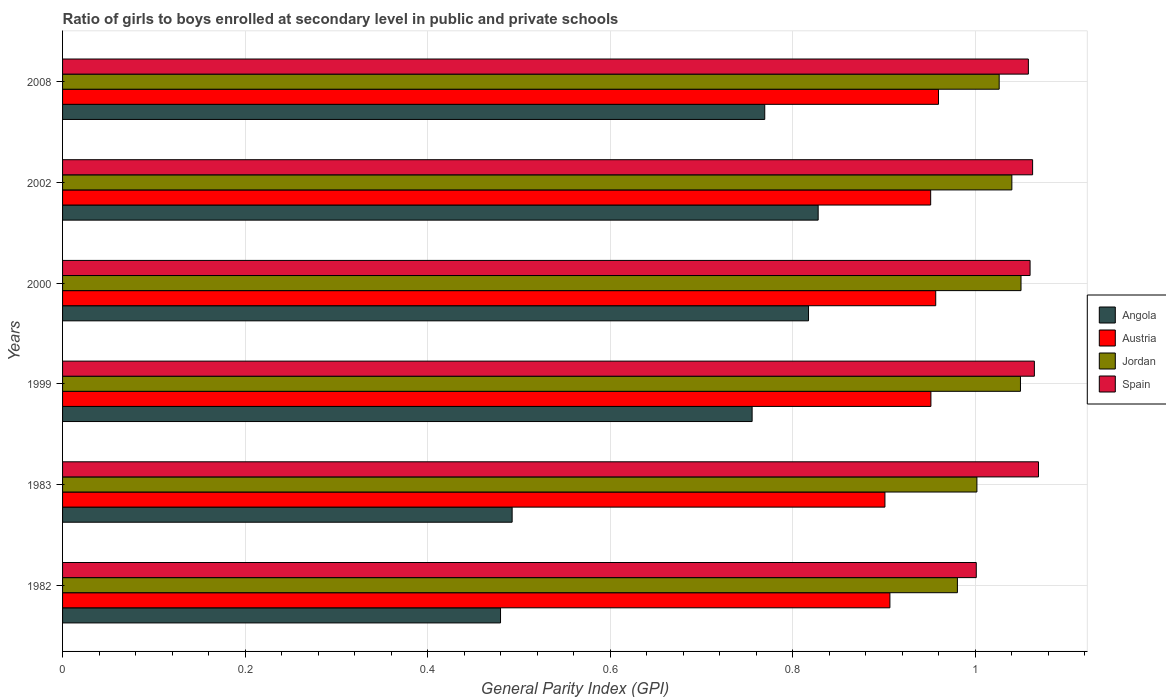How many groups of bars are there?
Give a very brief answer. 6. Are the number of bars per tick equal to the number of legend labels?
Keep it short and to the point. Yes. Are the number of bars on each tick of the Y-axis equal?
Give a very brief answer. Yes. How many bars are there on the 3rd tick from the top?
Provide a succinct answer. 4. How many bars are there on the 5th tick from the bottom?
Provide a short and direct response. 4. What is the label of the 1st group of bars from the top?
Your response must be concise. 2008. What is the general parity index in Angola in 1982?
Give a very brief answer. 0.48. Across all years, what is the maximum general parity index in Angola?
Ensure brevity in your answer.  0.83. Across all years, what is the minimum general parity index in Spain?
Provide a succinct answer. 1. In which year was the general parity index in Austria maximum?
Offer a very short reply. 2008. In which year was the general parity index in Austria minimum?
Your response must be concise. 1983. What is the total general parity index in Jordan in the graph?
Offer a terse response. 6.15. What is the difference between the general parity index in Angola in 1983 and that in 2002?
Ensure brevity in your answer.  -0.34. What is the difference between the general parity index in Jordan in 1983 and the general parity index in Angola in 1999?
Offer a terse response. 0.25. What is the average general parity index in Spain per year?
Your answer should be compact. 1.05. In the year 1999, what is the difference between the general parity index in Austria and general parity index in Angola?
Give a very brief answer. 0.2. What is the ratio of the general parity index in Spain in 1999 to that in 2000?
Provide a short and direct response. 1. Is the difference between the general parity index in Austria in 2000 and 2008 greater than the difference between the general parity index in Angola in 2000 and 2008?
Keep it short and to the point. No. What is the difference between the highest and the second highest general parity index in Jordan?
Provide a succinct answer. 0. What is the difference between the highest and the lowest general parity index in Angola?
Offer a very short reply. 0.35. Is the sum of the general parity index in Austria in 1982 and 2008 greater than the maximum general parity index in Angola across all years?
Provide a succinct answer. Yes. Is it the case that in every year, the sum of the general parity index in Austria and general parity index in Angola is greater than the sum of general parity index in Jordan and general parity index in Spain?
Your response must be concise. No. What does the 3rd bar from the top in 1982 represents?
Offer a terse response. Austria. What does the 3rd bar from the bottom in 2002 represents?
Your answer should be compact. Jordan. How many bars are there?
Ensure brevity in your answer.  24. What is the difference between two consecutive major ticks on the X-axis?
Your answer should be very brief. 0.2. Does the graph contain grids?
Provide a succinct answer. Yes. How many legend labels are there?
Offer a very short reply. 4. How are the legend labels stacked?
Offer a very short reply. Vertical. What is the title of the graph?
Make the answer very short. Ratio of girls to boys enrolled at secondary level in public and private schools. Does "Faeroe Islands" appear as one of the legend labels in the graph?
Keep it short and to the point. No. What is the label or title of the X-axis?
Offer a terse response. General Parity Index (GPI). What is the label or title of the Y-axis?
Ensure brevity in your answer.  Years. What is the General Parity Index (GPI) of Angola in 1982?
Make the answer very short. 0.48. What is the General Parity Index (GPI) of Austria in 1982?
Offer a terse response. 0.91. What is the General Parity Index (GPI) in Jordan in 1982?
Your answer should be very brief. 0.98. What is the General Parity Index (GPI) of Spain in 1982?
Your response must be concise. 1. What is the General Parity Index (GPI) in Angola in 1983?
Offer a very short reply. 0.49. What is the General Parity Index (GPI) of Austria in 1983?
Give a very brief answer. 0.9. What is the General Parity Index (GPI) in Jordan in 1983?
Ensure brevity in your answer.  1. What is the General Parity Index (GPI) in Spain in 1983?
Give a very brief answer. 1.07. What is the General Parity Index (GPI) in Angola in 1999?
Provide a succinct answer. 0.76. What is the General Parity Index (GPI) of Austria in 1999?
Your answer should be very brief. 0.95. What is the General Parity Index (GPI) in Jordan in 1999?
Ensure brevity in your answer.  1.05. What is the General Parity Index (GPI) of Spain in 1999?
Your answer should be very brief. 1.06. What is the General Parity Index (GPI) in Angola in 2000?
Provide a short and direct response. 0.82. What is the General Parity Index (GPI) of Austria in 2000?
Ensure brevity in your answer.  0.96. What is the General Parity Index (GPI) of Jordan in 2000?
Your response must be concise. 1.05. What is the General Parity Index (GPI) in Spain in 2000?
Make the answer very short. 1.06. What is the General Parity Index (GPI) in Angola in 2002?
Offer a terse response. 0.83. What is the General Parity Index (GPI) in Austria in 2002?
Ensure brevity in your answer.  0.95. What is the General Parity Index (GPI) in Jordan in 2002?
Offer a terse response. 1.04. What is the General Parity Index (GPI) of Spain in 2002?
Ensure brevity in your answer.  1.06. What is the General Parity Index (GPI) in Angola in 2008?
Keep it short and to the point. 0.77. What is the General Parity Index (GPI) of Austria in 2008?
Keep it short and to the point. 0.96. What is the General Parity Index (GPI) in Jordan in 2008?
Give a very brief answer. 1.03. What is the General Parity Index (GPI) in Spain in 2008?
Your answer should be compact. 1.06. Across all years, what is the maximum General Parity Index (GPI) in Angola?
Offer a very short reply. 0.83. Across all years, what is the maximum General Parity Index (GPI) in Austria?
Keep it short and to the point. 0.96. Across all years, what is the maximum General Parity Index (GPI) in Jordan?
Offer a very short reply. 1.05. Across all years, what is the maximum General Parity Index (GPI) in Spain?
Give a very brief answer. 1.07. Across all years, what is the minimum General Parity Index (GPI) of Angola?
Make the answer very short. 0.48. Across all years, what is the minimum General Parity Index (GPI) in Austria?
Your answer should be very brief. 0.9. Across all years, what is the minimum General Parity Index (GPI) in Jordan?
Offer a terse response. 0.98. Across all years, what is the minimum General Parity Index (GPI) of Spain?
Offer a very short reply. 1. What is the total General Parity Index (GPI) of Angola in the graph?
Keep it short and to the point. 4.14. What is the total General Parity Index (GPI) of Austria in the graph?
Give a very brief answer. 5.63. What is the total General Parity Index (GPI) of Jordan in the graph?
Provide a short and direct response. 6.15. What is the total General Parity Index (GPI) of Spain in the graph?
Offer a very short reply. 6.32. What is the difference between the General Parity Index (GPI) of Angola in 1982 and that in 1983?
Provide a succinct answer. -0.01. What is the difference between the General Parity Index (GPI) in Austria in 1982 and that in 1983?
Make the answer very short. 0.01. What is the difference between the General Parity Index (GPI) in Jordan in 1982 and that in 1983?
Offer a very short reply. -0.02. What is the difference between the General Parity Index (GPI) in Spain in 1982 and that in 1983?
Offer a very short reply. -0.07. What is the difference between the General Parity Index (GPI) of Angola in 1982 and that in 1999?
Provide a succinct answer. -0.28. What is the difference between the General Parity Index (GPI) in Austria in 1982 and that in 1999?
Your answer should be compact. -0.04. What is the difference between the General Parity Index (GPI) in Jordan in 1982 and that in 1999?
Ensure brevity in your answer.  -0.07. What is the difference between the General Parity Index (GPI) of Spain in 1982 and that in 1999?
Provide a succinct answer. -0.06. What is the difference between the General Parity Index (GPI) of Angola in 1982 and that in 2000?
Give a very brief answer. -0.34. What is the difference between the General Parity Index (GPI) of Austria in 1982 and that in 2000?
Ensure brevity in your answer.  -0.05. What is the difference between the General Parity Index (GPI) in Jordan in 1982 and that in 2000?
Your answer should be compact. -0.07. What is the difference between the General Parity Index (GPI) in Spain in 1982 and that in 2000?
Offer a very short reply. -0.06. What is the difference between the General Parity Index (GPI) in Angola in 1982 and that in 2002?
Give a very brief answer. -0.35. What is the difference between the General Parity Index (GPI) in Austria in 1982 and that in 2002?
Offer a very short reply. -0.04. What is the difference between the General Parity Index (GPI) of Jordan in 1982 and that in 2002?
Offer a very short reply. -0.06. What is the difference between the General Parity Index (GPI) of Spain in 1982 and that in 2002?
Offer a terse response. -0.06. What is the difference between the General Parity Index (GPI) of Angola in 1982 and that in 2008?
Provide a succinct answer. -0.29. What is the difference between the General Parity Index (GPI) in Austria in 1982 and that in 2008?
Offer a very short reply. -0.05. What is the difference between the General Parity Index (GPI) in Jordan in 1982 and that in 2008?
Your response must be concise. -0.05. What is the difference between the General Parity Index (GPI) in Spain in 1982 and that in 2008?
Offer a very short reply. -0.06. What is the difference between the General Parity Index (GPI) in Angola in 1983 and that in 1999?
Your response must be concise. -0.26. What is the difference between the General Parity Index (GPI) in Austria in 1983 and that in 1999?
Your response must be concise. -0.05. What is the difference between the General Parity Index (GPI) of Jordan in 1983 and that in 1999?
Offer a very short reply. -0.05. What is the difference between the General Parity Index (GPI) of Spain in 1983 and that in 1999?
Make the answer very short. 0. What is the difference between the General Parity Index (GPI) in Angola in 1983 and that in 2000?
Offer a terse response. -0.32. What is the difference between the General Parity Index (GPI) in Austria in 1983 and that in 2000?
Offer a very short reply. -0.06. What is the difference between the General Parity Index (GPI) in Jordan in 1983 and that in 2000?
Give a very brief answer. -0.05. What is the difference between the General Parity Index (GPI) of Spain in 1983 and that in 2000?
Offer a terse response. 0.01. What is the difference between the General Parity Index (GPI) of Angola in 1983 and that in 2002?
Offer a very short reply. -0.34. What is the difference between the General Parity Index (GPI) of Austria in 1983 and that in 2002?
Keep it short and to the point. -0.05. What is the difference between the General Parity Index (GPI) in Jordan in 1983 and that in 2002?
Provide a short and direct response. -0.04. What is the difference between the General Parity Index (GPI) in Spain in 1983 and that in 2002?
Give a very brief answer. 0.01. What is the difference between the General Parity Index (GPI) in Angola in 1983 and that in 2008?
Keep it short and to the point. -0.28. What is the difference between the General Parity Index (GPI) of Austria in 1983 and that in 2008?
Offer a very short reply. -0.06. What is the difference between the General Parity Index (GPI) in Jordan in 1983 and that in 2008?
Ensure brevity in your answer.  -0.02. What is the difference between the General Parity Index (GPI) in Spain in 1983 and that in 2008?
Offer a very short reply. 0.01. What is the difference between the General Parity Index (GPI) in Angola in 1999 and that in 2000?
Make the answer very short. -0.06. What is the difference between the General Parity Index (GPI) of Austria in 1999 and that in 2000?
Offer a terse response. -0.01. What is the difference between the General Parity Index (GPI) of Jordan in 1999 and that in 2000?
Provide a short and direct response. -0. What is the difference between the General Parity Index (GPI) of Spain in 1999 and that in 2000?
Give a very brief answer. 0. What is the difference between the General Parity Index (GPI) in Angola in 1999 and that in 2002?
Provide a short and direct response. -0.07. What is the difference between the General Parity Index (GPI) of Jordan in 1999 and that in 2002?
Provide a succinct answer. 0.01. What is the difference between the General Parity Index (GPI) of Spain in 1999 and that in 2002?
Your response must be concise. 0. What is the difference between the General Parity Index (GPI) in Angola in 1999 and that in 2008?
Offer a terse response. -0.01. What is the difference between the General Parity Index (GPI) of Austria in 1999 and that in 2008?
Your response must be concise. -0.01. What is the difference between the General Parity Index (GPI) of Jordan in 1999 and that in 2008?
Offer a very short reply. 0.02. What is the difference between the General Parity Index (GPI) in Spain in 1999 and that in 2008?
Your answer should be compact. 0.01. What is the difference between the General Parity Index (GPI) of Angola in 2000 and that in 2002?
Make the answer very short. -0.01. What is the difference between the General Parity Index (GPI) in Austria in 2000 and that in 2002?
Provide a short and direct response. 0.01. What is the difference between the General Parity Index (GPI) in Jordan in 2000 and that in 2002?
Provide a short and direct response. 0.01. What is the difference between the General Parity Index (GPI) of Spain in 2000 and that in 2002?
Give a very brief answer. -0. What is the difference between the General Parity Index (GPI) in Angola in 2000 and that in 2008?
Keep it short and to the point. 0.05. What is the difference between the General Parity Index (GPI) of Austria in 2000 and that in 2008?
Offer a very short reply. -0. What is the difference between the General Parity Index (GPI) of Jordan in 2000 and that in 2008?
Offer a terse response. 0.02. What is the difference between the General Parity Index (GPI) in Spain in 2000 and that in 2008?
Make the answer very short. 0. What is the difference between the General Parity Index (GPI) of Angola in 2002 and that in 2008?
Ensure brevity in your answer.  0.06. What is the difference between the General Parity Index (GPI) of Austria in 2002 and that in 2008?
Ensure brevity in your answer.  -0.01. What is the difference between the General Parity Index (GPI) of Jordan in 2002 and that in 2008?
Your response must be concise. 0.01. What is the difference between the General Parity Index (GPI) of Spain in 2002 and that in 2008?
Provide a succinct answer. 0. What is the difference between the General Parity Index (GPI) in Angola in 1982 and the General Parity Index (GPI) in Austria in 1983?
Keep it short and to the point. -0.42. What is the difference between the General Parity Index (GPI) in Angola in 1982 and the General Parity Index (GPI) in Jordan in 1983?
Provide a short and direct response. -0.52. What is the difference between the General Parity Index (GPI) of Angola in 1982 and the General Parity Index (GPI) of Spain in 1983?
Your answer should be very brief. -0.59. What is the difference between the General Parity Index (GPI) of Austria in 1982 and the General Parity Index (GPI) of Jordan in 1983?
Make the answer very short. -0.1. What is the difference between the General Parity Index (GPI) in Austria in 1982 and the General Parity Index (GPI) in Spain in 1983?
Provide a short and direct response. -0.16. What is the difference between the General Parity Index (GPI) in Jordan in 1982 and the General Parity Index (GPI) in Spain in 1983?
Your answer should be compact. -0.09. What is the difference between the General Parity Index (GPI) in Angola in 1982 and the General Parity Index (GPI) in Austria in 1999?
Provide a succinct answer. -0.47. What is the difference between the General Parity Index (GPI) in Angola in 1982 and the General Parity Index (GPI) in Jordan in 1999?
Offer a very short reply. -0.57. What is the difference between the General Parity Index (GPI) of Angola in 1982 and the General Parity Index (GPI) of Spain in 1999?
Your answer should be compact. -0.58. What is the difference between the General Parity Index (GPI) of Austria in 1982 and the General Parity Index (GPI) of Jordan in 1999?
Offer a terse response. -0.14. What is the difference between the General Parity Index (GPI) of Austria in 1982 and the General Parity Index (GPI) of Spain in 1999?
Provide a succinct answer. -0.16. What is the difference between the General Parity Index (GPI) of Jordan in 1982 and the General Parity Index (GPI) of Spain in 1999?
Make the answer very short. -0.08. What is the difference between the General Parity Index (GPI) of Angola in 1982 and the General Parity Index (GPI) of Austria in 2000?
Ensure brevity in your answer.  -0.48. What is the difference between the General Parity Index (GPI) in Angola in 1982 and the General Parity Index (GPI) in Jordan in 2000?
Your answer should be very brief. -0.57. What is the difference between the General Parity Index (GPI) in Angola in 1982 and the General Parity Index (GPI) in Spain in 2000?
Ensure brevity in your answer.  -0.58. What is the difference between the General Parity Index (GPI) in Austria in 1982 and the General Parity Index (GPI) in Jordan in 2000?
Ensure brevity in your answer.  -0.14. What is the difference between the General Parity Index (GPI) of Austria in 1982 and the General Parity Index (GPI) of Spain in 2000?
Offer a terse response. -0.15. What is the difference between the General Parity Index (GPI) in Jordan in 1982 and the General Parity Index (GPI) in Spain in 2000?
Provide a short and direct response. -0.08. What is the difference between the General Parity Index (GPI) of Angola in 1982 and the General Parity Index (GPI) of Austria in 2002?
Make the answer very short. -0.47. What is the difference between the General Parity Index (GPI) of Angola in 1982 and the General Parity Index (GPI) of Jordan in 2002?
Provide a short and direct response. -0.56. What is the difference between the General Parity Index (GPI) of Angola in 1982 and the General Parity Index (GPI) of Spain in 2002?
Offer a terse response. -0.58. What is the difference between the General Parity Index (GPI) of Austria in 1982 and the General Parity Index (GPI) of Jordan in 2002?
Keep it short and to the point. -0.13. What is the difference between the General Parity Index (GPI) in Austria in 1982 and the General Parity Index (GPI) in Spain in 2002?
Your answer should be very brief. -0.16. What is the difference between the General Parity Index (GPI) in Jordan in 1982 and the General Parity Index (GPI) in Spain in 2002?
Make the answer very short. -0.08. What is the difference between the General Parity Index (GPI) in Angola in 1982 and the General Parity Index (GPI) in Austria in 2008?
Keep it short and to the point. -0.48. What is the difference between the General Parity Index (GPI) in Angola in 1982 and the General Parity Index (GPI) in Jordan in 2008?
Offer a very short reply. -0.55. What is the difference between the General Parity Index (GPI) in Angola in 1982 and the General Parity Index (GPI) in Spain in 2008?
Provide a short and direct response. -0.58. What is the difference between the General Parity Index (GPI) of Austria in 1982 and the General Parity Index (GPI) of Jordan in 2008?
Your answer should be very brief. -0.12. What is the difference between the General Parity Index (GPI) in Austria in 1982 and the General Parity Index (GPI) in Spain in 2008?
Give a very brief answer. -0.15. What is the difference between the General Parity Index (GPI) of Jordan in 1982 and the General Parity Index (GPI) of Spain in 2008?
Your response must be concise. -0.08. What is the difference between the General Parity Index (GPI) in Angola in 1983 and the General Parity Index (GPI) in Austria in 1999?
Keep it short and to the point. -0.46. What is the difference between the General Parity Index (GPI) in Angola in 1983 and the General Parity Index (GPI) in Jordan in 1999?
Keep it short and to the point. -0.56. What is the difference between the General Parity Index (GPI) of Angola in 1983 and the General Parity Index (GPI) of Spain in 1999?
Offer a very short reply. -0.57. What is the difference between the General Parity Index (GPI) of Austria in 1983 and the General Parity Index (GPI) of Jordan in 1999?
Provide a succinct answer. -0.15. What is the difference between the General Parity Index (GPI) in Austria in 1983 and the General Parity Index (GPI) in Spain in 1999?
Your answer should be compact. -0.16. What is the difference between the General Parity Index (GPI) in Jordan in 1983 and the General Parity Index (GPI) in Spain in 1999?
Keep it short and to the point. -0.06. What is the difference between the General Parity Index (GPI) in Angola in 1983 and the General Parity Index (GPI) in Austria in 2000?
Keep it short and to the point. -0.46. What is the difference between the General Parity Index (GPI) in Angola in 1983 and the General Parity Index (GPI) in Jordan in 2000?
Ensure brevity in your answer.  -0.56. What is the difference between the General Parity Index (GPI) of Angola in 1983 and the General Parity Index (GPI) of Spain in 2000?
Your answer should be very brief. -0.57. What is the difference between the General Parity Index (GPI) of Austria in 1983 and the General Parity Index (GPI) of Jordan in 2000?
Provide a succinct answer. -0.15. What is the difference between the General Parity Index (GPI) in Austria in 1983 and the General Parity Index (GPI) in Spain in 2000?
Provide a succinct answer. -0.16. What is the difference between the General Parity Index (GPI) in Jordan in 1983 and the General Parity Index (GPI) in Spain in 2000?
Your answer should be compact. -0.06. What is the difference between the General Parity Index (GPI) in Angola in 1983 and the General Parity Index (GPI) in Austria in 2002?
Keep it short and to the point. -0.46. What is the difference between the General Parity Index (GPI) of Angola in 1983 and the General Parity Index (GPI) of Jordan in 2002?
Offer a terse response. -0.55. What is the difference between the General Parity Index (GPI) in Angola in 1983 and the General Parity Index (GPI) in Spain in 2002?
Your answer should be very brief. -0.57. What is the difference between the General Parity Index (GPI) in Austria in 1983 and the General Parity Index (GPI) in Jordan in 2002?
Give a very brief answer. -0.14. What is the difference between the General Parity Index (GPI) in Austria in 1983 and the General Parity Index (GPI) in Spain in 2002?
Offer a terse response. -0.16. What is the difference between the General Parity Index (GPI) in Jordan in 1983 and the General Parity Index (GPI) in Spain in 2002?
Give a very brief answer. -0.06. What is the difference between the General Parity Index (GPI) in Angola in 1983 and the General Parity Index (GPI) in Austria in 2008?
Keep it short and to the point. -0.47. What is the difference between the General Parity Index (GPI) of Angola in 1983 and the General Parity Index (GPI) of Jordan in 2008?
Your answer should be very brief. -0.53. What is the difference between the General Parity Index (GPI) in Angola in 1983 and the General Parity Index (GPI) in Spain in 2008?
Keep it short and to the point. -0.57. What is the difference between the General Parity Index (GPI) of Austria in 1983 and the General Parity Index (GPI) of Jordan in 2008?
Your response must be concise. -0.13. What is the difference between the General Parity Index (GPI) in Austria in 1983 and the General Parity Index (GPI) in Spain in 2008?
Offer a very short reply. -0.16. What is the difference between the General Parity Index (GPI) in Jordan in 1983 and the General Parity Index (GPI) in Spain in 2008?
Offer a very short reply. -0.06. What is the difference between the General Parity Index (GPI) in Angola in 1999 and the General Parity Index (GPI) in Austria in 2000?
Your response must be concise. -0.2. What is the difference between the General Parity Index (GPI) in Angola in 1999 and the General Parity Index (GPI) in Jordan in 2000?
Offer a terse response. -0.29. What is the difference between the General Parity Index (GPI) of Angola in 1999 and the General Parity Index (GPI) of Spain in 2000?
Provide a succinct answer. -0.3. What is the difference between the General Parity Index (GPI) of Austria in 1999 and the General Parity Index (GPI) of Jordan in 2000?
Provide a succinct answer. -0.1. What is the difference between the General Parity Index (GPI) of Austria in 1999 and the General Parity Index (GPI) of Spain in 2000?
Provide a succinct answer. -0.11. What is the difference between the General Parity Index (GPI) in Jordan in 1999 and the General Parity Index (GPI) in Spain in 2000?
Your response must be concise. -0.01. What is the difference between the General Parity Index (GPI) in Angola in 1999 and the General Parity Index (GPI) in Austria in 2002?
Your answer should be compact. -0.2. What is the difference between the General Parity Index (GPI) in Angola in 1999 and the General Parity Index (GPI) in Jordan in 2002?
Your response must be concise. -0.28. What is the difference between the General Parity Index (GPI) in Angola in 1999 and the General Parity Index (GPI) in Spain in 2002?
Your answer should be compact. -0.31. What is the difference between the General Parity Index (GPI) of Austria in 1999 and the General Parity Index (GPI) of Jordan in 2002?
Your answer should be compact. -0.09. What is the difference between the General Parity Index (GPI) of Austria in 1999 and the General Parity Index (GPI) of Spain in 2002?
Provide a succinct answer. -0.11. What is the difference between the General Parity Index (GPI) in Jordan in 1999 and the General Parity Index (GPI) in Spain in 2002?
Your answer should be compact. -0.01. What is the difference between the General Parity Index (GPI) in Angola in 1999 and the General Parity Index (GPI) in Austria in 2008?
Give a very brief answer. -0.2. What is the difference between the General Parity Index (GPI) in Angola in 1999 and the General Parity Index (GPI) in Jordan in 2008?
Your response must be concise. -0.27. What is the difference between the General Parity Index (GPI) in Angola in 1999 and the General Parity Index (GPI) in Spain in 2008?
Offer a very short reply. -0.3. What is the difference between the General Parity Index (GPI) in Austria in 1999 and the General Parity Index (GPI) in Jordan in 2008?
Your answer should be very brief. -0.07. What is the difference between the General Parity Index (GPI) of Austria in 1999 and the General Parity Index (GPI) of Spain in 2008?
Keep it short and to the point. -0.11. What is the difference between the General Parity Index (GPI) of Jordan in 1999 and the General Parity Index (GPI) of Spain in 2008?
Keep it short and to the point. -0.01. What is the difference between the General Parity Index (GPI) in Angola in 2000 and the General Parity Index (GPI) in Austria in 2002?
Offer a very short reply. -0.13. What is the difference between the General Parity Index (GPI) of Angola in 2000 and the General Parity Index (GPI) of Jordan in 2002?
Provide a short and direct response. -0.22. What is the difference between the General Parity Index (GPI) of Angola in 2000 and the General Parity Index (GPI) of Spain in 2002?
Offer a terse response. -0.25. What is the difference between the General Parity Index (GPI) in Austria in 2000 and the General Parity Index (GPI) in Jordan in 2002?
Your response must be concise. -0.08. What is the difference between the General Parity Index (GPI) of Austria in 2000 and the General Parity Index (GPI) of Spain in 2002?
Offer a very short reply. -0.11. What is the difference between the General Parity Index (GPI) in Jordan in 2000 and the General Parity Index (GPI) in Spain in 2002?
Provide a short and direct response. -0.01. What is the difference between the General Parity Index (GPI) of Angola in 2000 and the General Parity Index (GPI) of Austria in 2008?
Provide a short and direct response. -0.14. What is the difference between the General Parity Index (GPI) of Angola in 2000 and the General Parity Index (GPI) of Jordan in 2008?
Offer a very short reply. -0.21. What is the difference between the General Parity Index (GPI) of Angola in 2000 and the General Parity Index (GPI) of Spain in 2008?
Provide a succinct answer. -0.24. What is the difference between the General Parity Index (GPI) in Austria in 2000 and the General Parity Index (GPI) in Jordan in 2008?
Offer a terse response. -0.07. What is the difference between the General Parity Index (GPI) in Austria in 2000 and the General Parity Index (GPI) in Spain in 2008?
Your response must be concise. -0.1. What is the difference between the General Parity Index (GPI) of Jordan in 2000 and the General Parity Index (GPI) of Spain in 2008?
Your answer should be compact. -0.01. What is the difference between the General Parity Index (GPI) of Angola in 2002 and the General Parity Index (GPI) of Austria in 2008?
Provide a short and direct response. -0.13. What is the difference between the General Parity Index (GPI) of Angola in 2002 and the General Parity Index (GPI) of Jordan in 2008?
Your answer should be very brief. -0.2. What is the difference between the General Parity Index (GPI) of Angola in 2002 and the General Parity Index (GPI) of Spain in 2008?
Provide a short and direct response. -0.23. What is the difference between the General Parity Index (GPI) in Austria in 2002 and the General Parity Index (GPI) in Jordan in 2008?
Give a very brief answer. -0.08. What is the difference between the General Parity Index (GPI) of Austria in 2002 and the General Parity Index (GPI) of Spain in 2008?
Your answer should be very brief. -0.11. What is the difference between the General Parity Index (GPI) of Jordan in 2002 and the General Parity Index (GPI) of Spain in 2008?
Your answer should be compact. -0.02. What is the average General Parity Index (GPI) in Angola per year?
Your answer should be very brief. 0.69. What is the average General Parity Index (GPI) in Austria per year?
Offer a very short reply. 0.94. What is the average General Parity Index (GPI) of Jordan per year?
Your answer should be very brief. 1.02. What is the average General Parity Index (GPI) in Spain per year?
Provide a short and direct response. 1.05. In the year 1982, what is the difference between the General Parity Index (GPI) of Angola and General Parity Index (GPI) of Austria?
Ensure brevity in your answer.  -0.43. In the year 1982, what is the difference between the General Parity Index (GPI) in Angola and General Parity Index (GPI) in Jordan?
Your response must be concise. -0.5. In the year 1982, what is the difference between the General Parity Index (GPI) in Angola and General Parity Index (GPI) in Spain?
Your answer should be compact. -0.52. In the year 1982, what is the difference between the General Parity Index (GPI) of Austria and General Parity Index (GPI) of Jordan?
Your answer should be compact. -0.07. In the year 1982, what is the difference between the General Parity Index (GPI) of Austria and General Parity Index (GPI) of Spain?
Your answer should be compact. -0.09. In the year 1982, what is the difference between the General Parity Index (GPI) of Jordan and General Parity Index (GPI) of Spain?
Ensure brevity in your answer.  -0.02. In the year 1983, what is the difference between the General Parity Index (GPI) of Angola and General Parity Index (GPI) of Austria?
Make the answer very short. -0.41. In the year 1983, what is the difference between the General Parity Index (GPI) in Angola and General Parity Index (GPI) in Jordan?
Provide a short and direct response. -0.51. In the year 1983, what is the difference between the General Parity Index (GPI) of Angola and General Parity Index (GPI) of Spain?
Offer a terse response. -0.58. In the year 1983, what is the difference between the General Parity Index (GPI) of Austria and General Parity Index (GPI) of Jordan?
Ensure brevity in your answer.  -0.1. In the year 1983, what is the difference between the General Parity Index (GPI) in Austria and General Parity Index (GPI) in Spain?
Your answer should be very brief. -0.17. In the year 1983, what is the difference between the General Parity Index (GPI) in Jordan and General Parity Index (GPI) in Spain?
Your response must be concise. -0.07. In the year 1999, what is the difference between the General Parity Index (GPI) of Angola and General Parity Index (GPI) of Austria?
Your answer should be compact. -0.2. In the year 1999, what is the difference between the General Parity Index (GPI) of Angola and General Parity Index (GPI) of Jordan?
Provide a succinct answer. -0.29. In the year 1999, what is the difference between the General Parity Index (GPI) in Angola and General Parity Index (GPI) in Spain?
Give a very brief answer. -0.31. In the year 1999, what is the difference between the General Parity Index (GPI) in Austria and General Parity Index (GPI) in Jordan?
Your answer should be compact. -0.1. In the year 1999, what is the difference between the General Parity Index (GPI) of Austria and General Parity Index (GPI) of Spain?
Ensure brevity in your answer.  -0.11. In the year 1999, what is the difference between the General Parity Index (GPI) of Jordan and General Parity Index (GPI) of Spain?
Give a very brief answer. -0.02. In the year 2000, what is the difference between the General Parity Index (GPI) in Angola and General Parity Index (GPI) in Austria?
Offer a terse response. -0.14. In the year 2000, what is the difference between the General Parity Index (GPI) in Angola and General Parity Index (GPI) in Jordan?
Your answer should be compact. -0.23. In the year 2000, what is the difference between the General Parity Index (GPI) in Angola and General Parity Index (GPI) in Spain?
Give a very brief answer. -0.24. In the year 2000, what is the difference between the General Parity Index (GPI) in Austria and General Parity Index (GPI) in Jordan?
Your answer should be very brief. -0.09. In the year 2000, what is the difference between the General Parity Index (GPI) of Austria and General Parity Index (GPI) of Spain?
Your answer should be compact. -0.1. In the year 2000, what is the difference between the General Parity Index (GPI) in Jordan and General Parity Index (GPI) in Spain?
Provide a short and direct response. -0.01. In the year 2002, what is the difference between the General Parity Index (GPI) in Angola and General Parity Index (GPI) in Austria?
Give a very brief answer. -0.12. In the year 2002, what is the difference between the General Parity Index (GPI) of Angola and General Parity Index (GPI) of Jordan?
Give a very brief answer. -0.21. In the year 2002, what is the difference between the General Parity Index (GPI) in Angola and General Parity Index (GPI) in Spain?
Give a very brief answer. -0.23. In the year 2002, what is the difference between the General Parity Index (GPI) in Austria and General Parity Index (GPI) in Jordan?
Keep it short and to the point. -0.09. In the year 2002, what is the difference between the General Parity Index (GPI) in Austria and General Parity Index (GPI) in Spain?
Offer a very short reply. -0.11. In the year 2002, what is the difference between the General Parity Index (GPI) in Jordan and General Parity Index (GPI) in Spain?
Offer a very short reply. -0.02. In the year 2008, what is the difference between the General Parity Index (GPI) in Angola and General Parity Index (GPI) in Austria?
Ensure brevity in your answer.  -0.19. In the year 2008, what is the difference between the General Parity Index (GPI) of Angola and General Parity Index (GPI) of Jordan?
Keep it short and to the point. -0.26. In the year 2008, what is the difference between the General Parity Index (GPI) of Angola and General Parity Index (GPI) of Spain?
Offer a very short reply. -0.29. In the year 2008, what is the difference between the General Parity Index (GPI) of Austria and General Parity Index (GPI) of Jordan?
Your response must be concise. -0.07. In the year 2008, what is the difference between the General Parity Index (GPI) of Austria and General Parity Index (GPI) of Spain?
Make the answer very short. -0.1. In the year 2008, what is the difference between the General Parity Index (GPI) in Jordan and General Parity Index (GPI) in Spain?
Provide a short and direct response. -0.03. What is the ratio of the General Parity Index (GPI) of Angola in 1982 to that in 1983?
Your response must be concise. 0.97. What is the ratio of the General Parity Index (GPI) in Jordan in 1982 to that in 1983?
Provide a short and direct response. 0.98. What is the ratio of the General Parity Index (GPI) of Spain in 1982 to that in 1983?
Your answer should be compact. 0.94. What is the ratio of the General Parity Index (GPI) in Angola in 1982 to that in 1999?
Make the answer very short. 0.64. What is the ratio of the General Parity Index (GPI) in Austria in 1982 to that in 1999?
Ensure brevity in your answer.  0.95. What is the ratio of the General Parity Index (GPI) in Jordan in 1982 to that in 1999?
Keep it short and to the point. 0.93. What is the ratio of the General Parity Index (GPI) in Spain in 1982 to that in 1999?
Offer a terse response. 0.94. What is the ratio of the General Parity Index (GPI) of Angola in 1982 to that in 2000?
Your response must be concise. 0.59. What is the ratio of the General Parity Index (GPI) of Austria in 1982 to that in 2000?
Provide a short and direct response. 0.95. What is the ratio of the General Parity Index (GPI) of Jordan in 1982 to that in 2000?
Provide a succinct answer. 0.93. What is the ratio of the General Parity Index (GPI) of Spain in 1982 to that in 2000?
Your answer should be compact. 0.94. What is the ratio of the General Parity Index (GPI) of Angola in 1982 to that in 2002?
Offer a very short reply. 0.58. What is the ratio of the General Parity Index (GPI) of Austria in 1982 to that in 2002?
Provide a succinct answer. 0.95. What is the ratio of the General Parity Index (GPI) of Jordan in 1982 to that in 2002?
Your answer should be very brief. 0.94. What is the ratio of the General Parity Index (GPI) in Spain in 1982 to that in 2002?
Your answer should be compact. 0.94. What is the ratio of the General Parity Index (GPI) of Angola in 1982 to that in 2008?
Provide a short and direct response. 0.62. What is the ratio of the General Parity Index (GPI) of Austria in 1982 to that in 2008?
Provide a succinct answer. 0.94. What is the ratio of the General Parity Index (GPI) of Jordan in 1982 to that in 2008?
Ensure brevity in your answer.  0.96. What is the ratio of the General Parity Index (GPI) of Spain in 1982 to that in 2008?
Provide a short and direct response. 0.95. What is the ratio of the General Parity Index (GPI) of Angola in 1983 to that in 1999?
Your answer should be very brief. 0.65. What is the ratio of the General Parity Index (GPI) of Austria in 1983 to that in 1999?
Ensure brevity in your answer.  0.95. What is the ratio of the General Parity Index (GPI) in Jordan in 1983 to that in 1999?
Offer a terse response. 0.95. What is the ratio of the General Parity Index (GPI) of Angola in 1983 to that in 2000?
Give a very brief answer. 0.6. What is the ratio of the General Parity Index (GPI) in Austria in 1983 to that in 2000?
Your response must be concise. 0.94. What is the ratio of the General Parity Index (GPI) in Jordan in 1983 to that in 2000?
Offer a terse response. 0.95. What is the ratio of the General Parity Index (GPI) of Spain in 1983 to that in 2000?
Ensure brevity in your answer.  1.01. What is the ratio of the General Parity Index (GPI) of Angola in 1983 to that in 2002?
Keep it short and to the point. 0.59. What is the ratio of the General Parity Index (GPI) in Austria in 1983 to that in 2002?
Your response must be concise. 0.95. What is the ratio of the General Parity Index (GPI) of Jordan in 1983 to that in 2002?
Your response must be concise. 0.96. What is the ratio of the General Parity Index (GPI) in Angola in 1983 to that in 2008?
Make the answer very short. 0.64. What is the ratio of the General Parity Index (GPI) of Austria in 1983 to that in 2008?
Make the answer very short. 0.94. What is the ratio of the General Parity Index (GPI) in Jordan in 1983 to that in 2008?
Offer a terse response. 0.98. What is the ratio of the General Parity Index (GPI) of Spain in 1983 to that in 2008?
Make the answer very short. 1.01. What is the ratio of the General Parity Index (GPI) of Angola in 1999 to that in 2000?
Ensure brevity in your answer.  0.92. What is the ratio of the General Parity Index (GPI) in Austria in 1999 to that in 2000?
Offer a very short reply. 0.99. What is the ratio of the General Parity Index (GPI) of Jordan in 1999 to that in 2000?
Ensure brevity in your answer.  1. What is the ratio of the General Parity Index (GPI) in Spain in 1999 to that in 2000?
Ensure brevity in your answer.  1. What is the ratio of the General Parity Index (GPI) of Angola in 1999 to that in 2002?
Provide a succinct answer. 0.91. What is the ratio of the General Parity Index (GPI) of Austria in 1999 to that in 2002?
Ensure brevity in your answer.  1. What is the ratio of the General Parity Index (GPI) in Jordan in 1999 to that in 2002?
Give a very brief answer. 1.01. What is the ratio of the General Parity Index (GPI) in Angola in 1999 to that in 2008?
Offer a very short reply. 0.98. What is the ratio of the General Parity Index (GPI) in Jordan in 1999 to that in 2008?
Give a very brief answer. 1.02. What is the ratio of the General Parity Index (GPI) in Spain in 1999 to that in 2008?
Provide a succinct answer. 1.01. What is the ratio of the General Parity Index (GPI) of Angola in 2000 to that in 2002?
Your answer should be compact. 0.99. What is the ratio of the General Parity Index (GPI) in Jordan in 2000 to that in 2002?
Your response must be concise. 1.01. What is the ratio of the General Parity Index (GPI) of Angola in 2000 to that in 2008?
Offer a very short reply. 1.06. What is the ratio of the General Parity Index (GPI) of Jordan in 2000 to that in 2008?
Ensure brevity in your answer.  1.02. What is the ratio of the General Parity Index (GPI) of Angola in 2002 to that in 2008?
Offer a terse response. 1.08. What is the ratio of the General Parity Index (GPI) of Jordan in 2002 to that in 2008?
Your answer should be very brief. 1.01. What is the difference between the highest and the second highest General Parity Index (GPI) of Angola?
Ensure brevity in your answer.  0.01. What is the difference between the highest and the second highest General Parity Index (GPI) of Austria?
Provide a short and direct response. 0. What is the difference between the highest and the second highest General Parity Index (GPI) in Jordan?
Your answer should be compact. 0. What is the difference between the highest and the second highest General Parity Index (GPI) of Spain?
Ensure brevity in your answer.  0. What is the difference between the highest and the lowest General Parity Index (GPI) of Angola?
Offer a terse response. 0.35. What is the difference between the highest and the lowest General Parity Index (GPI) in Austria?
Provide a short and direct response. 0.06. What is the difference between the highest and the lowest General Parity Index (GPI) in Jordan?
Ensure brevity in your answer.  0.07. What is the difference between the highest and the lowest General Parity Index (GPI) in Spain?
Provide a succinct answer. 0.07. 